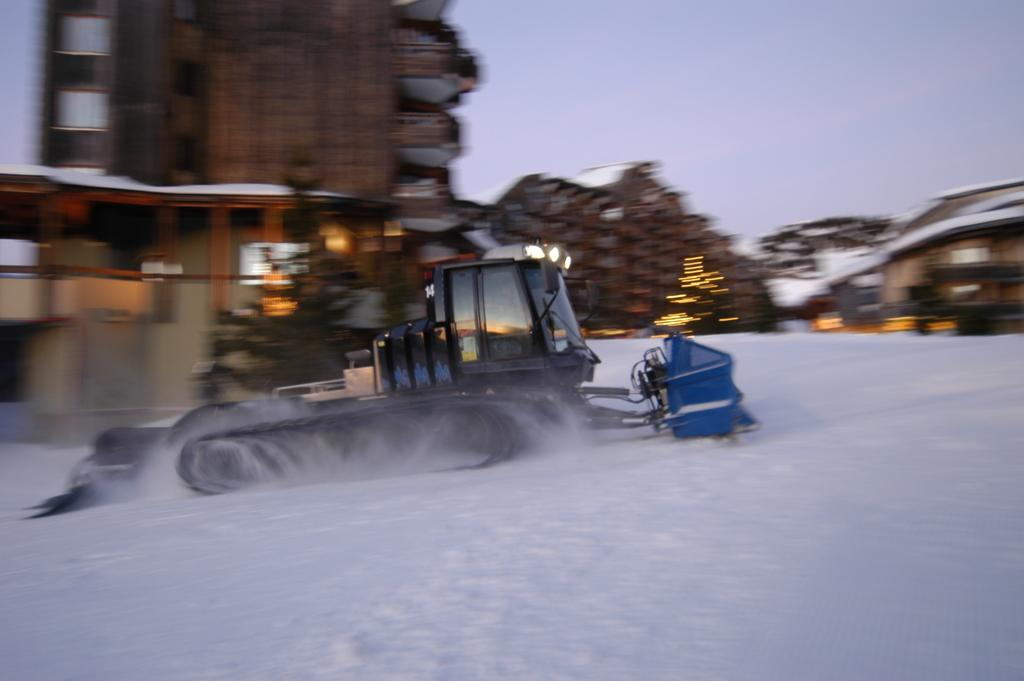What is the main subject of the image? There is a vehicle in the image. What is the condition of the ground beneath the vehicle? The vehicle is on the snow. What can be seen in the distance behind the vehicle? There are buildings and lights visible in the background of the image. What is the appearance of the sky in the image? The sky is visible in the background of the image. How would you describe the quality of the background in the image? The background is blurry. What type of breakfast is being served in the image? There is no breakfast present in the image; it features a vehicle on the snow with a blurry background. How does the dust affect the visibility of the vehicle in the image? There is no dust present in the image, so it does not affect the visibility of the vehicle. 